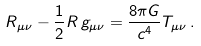Convert formula to latex. <formula><loc_0><loc_0><loc_500><loc_500>R _ { \mu \nu } - \frac { 1 } { 2 } R \, g _ { \mu \nu } = \frac { 8 \pi G } { c ^ { 4 } } T _ { \mu \nu } \, .</formula> 